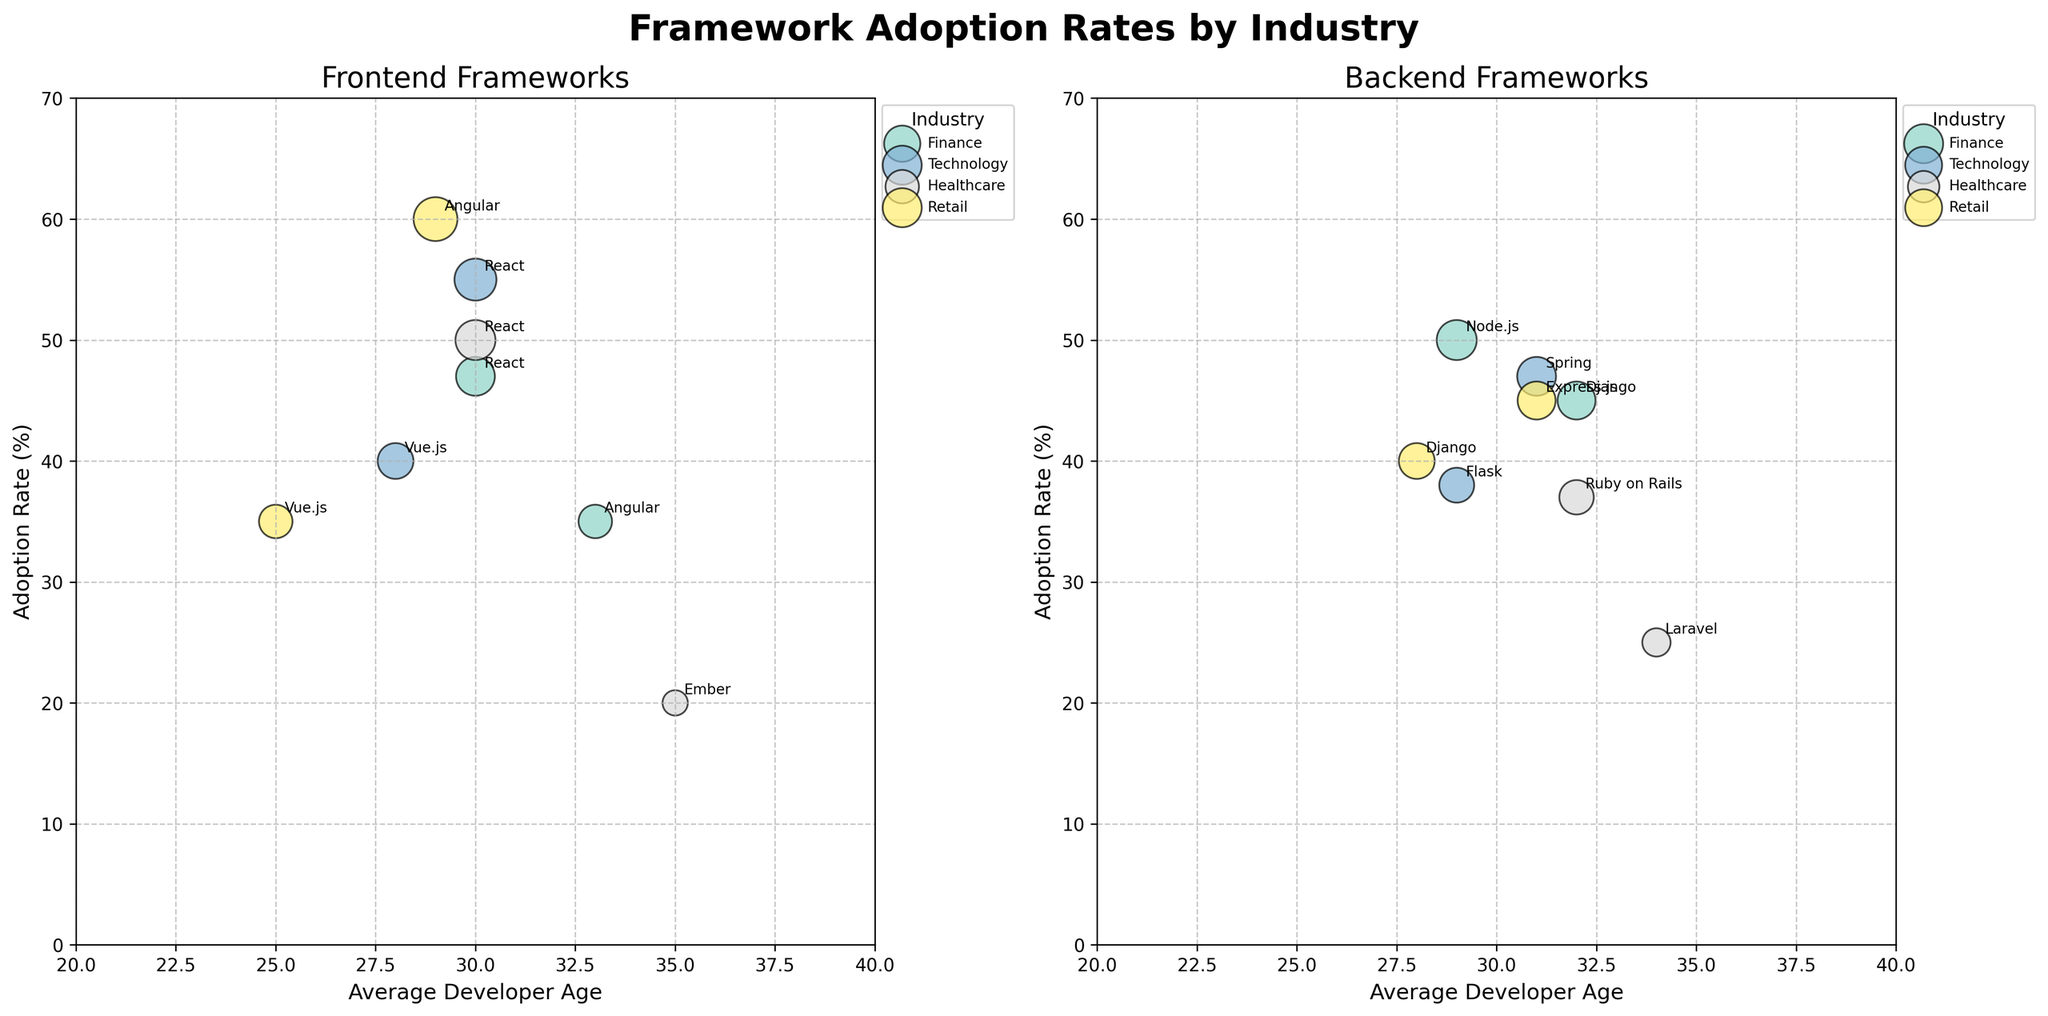What is the title of the figure? The title of the figure is normally the text displayed at the topmost part. Here, it seems bold and larger than other texts, located above the subplots.
Answer: Framework Adoption Rates by Industry What does each bubble represent in the figure? Each bubble represents a specific framework within an industry. The size of the bubble is proportional to the adoption rate of that framework.
Answer: Framework adoption rate Which industry has the largest bubble for frontend frameworks? The largest bubble represents the highest adoption rate. For frontend frameworks, Retail's Angular has the largest bubble at a 60% adoption rate.
Answer: Retail How does the average age of developers using React in Finance compare to those in Healthcare? The positions of the bubbles for React in Finance and Healthcare on the x-axis (average age) show that Healthcare developers are older. finance average age is 30, and healthcare average age is 30.
Answer: Same What is the adoption rate of Flask in the Technology industry? Identify the Flask label in the backend frameworks subplot and note the y-axis value corresponding to its bubble.
Answer: 38% Which backend framework has the highest adoption rate in the Technology industry? By examining the backend subplot, the largest bubble in Technology is Spring with an adoption rate of 47%.
Answer: Spring Compare the adoption rates of Django in Finance and Retail. Which one is higher? Locate the Django bubbles in both subplots and compare their sizes and positions on the y-axis. Finance Django is at 45%, and Retail Django is at 40%.
Answer: Finance Are there any industries where the average developer age for frontend frameworks exceeds 34? Check the x-axis values for frontend frameworks bubbles and see if any are greater than 34. In Healthcare, the Ember framework has an average developer age of 35.
Answer: Yes, Healthcare Which industry has the highest adoption rate for backend frameworks overall? Identify the tallest bubbles in the backend subplot for each industry. Finance has the highest at 50% for Node.js.
Answer: Finance What is the average developer experience level for the frontend frameworks in Technology? Note the labels next to the bubbles for frontend frameworks in Technology. Both React and Vue.js have labels indicating “Mid” and “Junior” respectively. The average developer experience level can be the average of mid (2-5 years) and junior (0-2 years). Note that the average is contextual; it should be around the mid-level mark.
Answer: Mid 